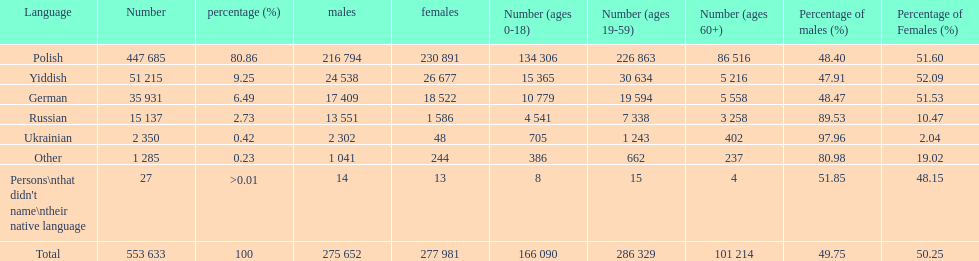How many languages have a name that is derived from a country? 4. 